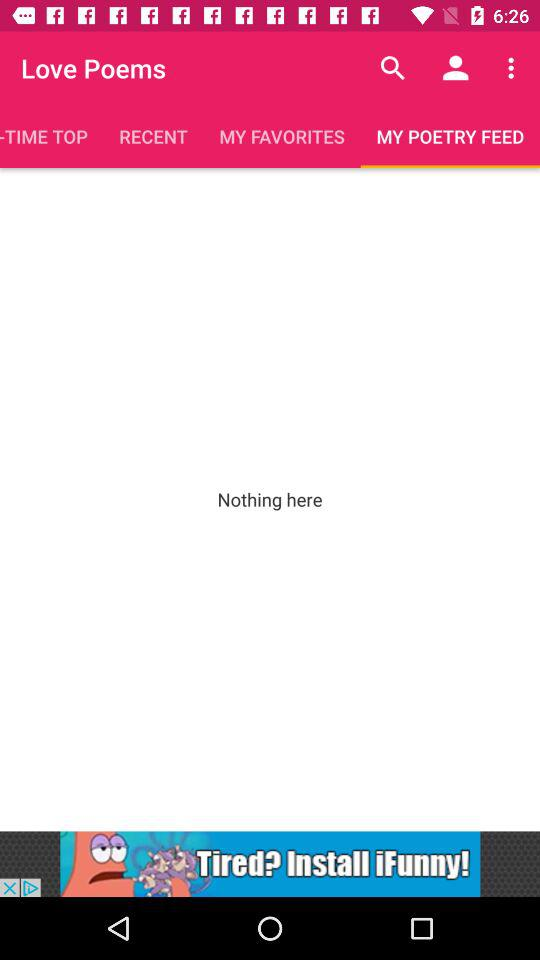Which tab am I on? The tab is "MY POETRY FEED". 